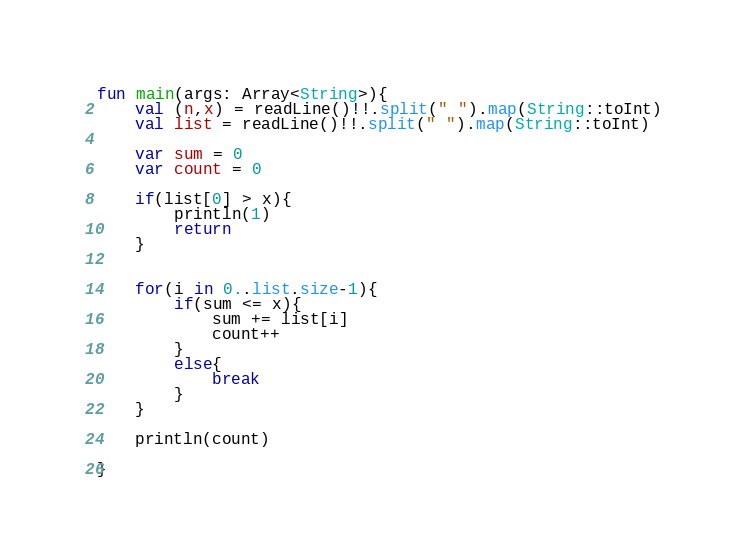Convert code to text. <code><loc_0><loc_0><loc_500><loc_500><_Kotlin_>fun main(args: Array<String>){
    val (n,x) = readLine()!!.split(" ").map(String::toInt)
    val list = readLine()!!.split(" ").map(String::toInt)

    var sum = 0
    var count = 0

    if(list[0] > x){
        println(1)
        return
    }


    for(i in 0..list.size-1){
        if(sum <= x){
            sum += list[i]
            count++
        }
        else{
            break
        }
    }

    println(count)

}</code> 